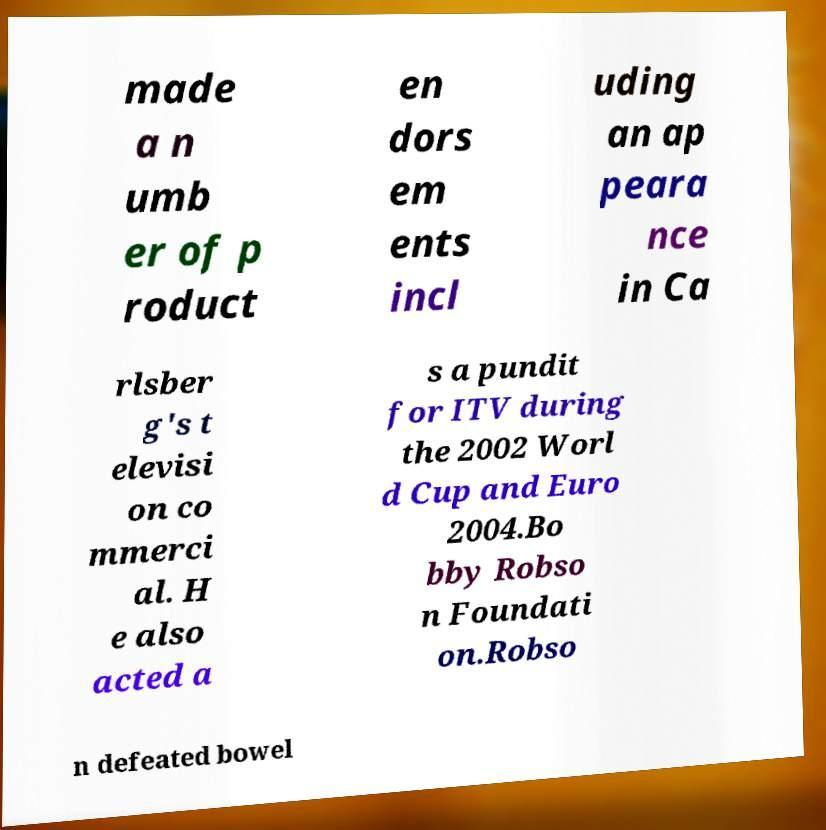Please identify and transcribe the text found in this image. made a n umb er of p roduct en dors em ents incl uding an ap peara nce in Ca rlsber g's t elevisi on co mmerci al. H e also acted a s a pundit for ITV during the 2002 Worl d Cup and Euro 2004.Bo bby Robso n Foundati on.Robso n defeated bowel 